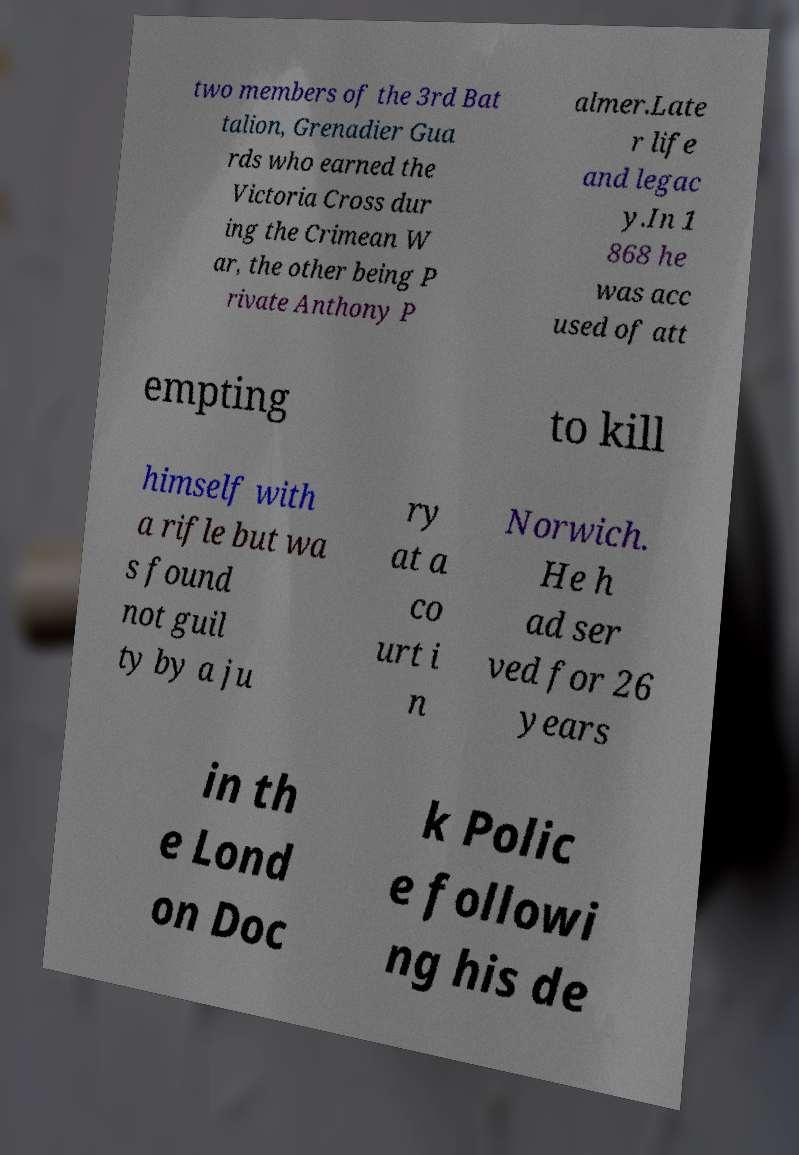Please identify and transcribe the text found in this image. two members of the 3rd Bat talion, Grenadier Gua rds who earned the Victoria Cross dur ing the Crimean W ar, the other being P rivate Anthony P almer.Late r life and legac y.In 1 868 he was acc used of att empting to kill himself with a rifle but wa s found not guil ty by a ju ry at a co urt i n Norwich. He h ad ser ved for 26 years in th e Lond on Doc k Polic e followi ng his de 